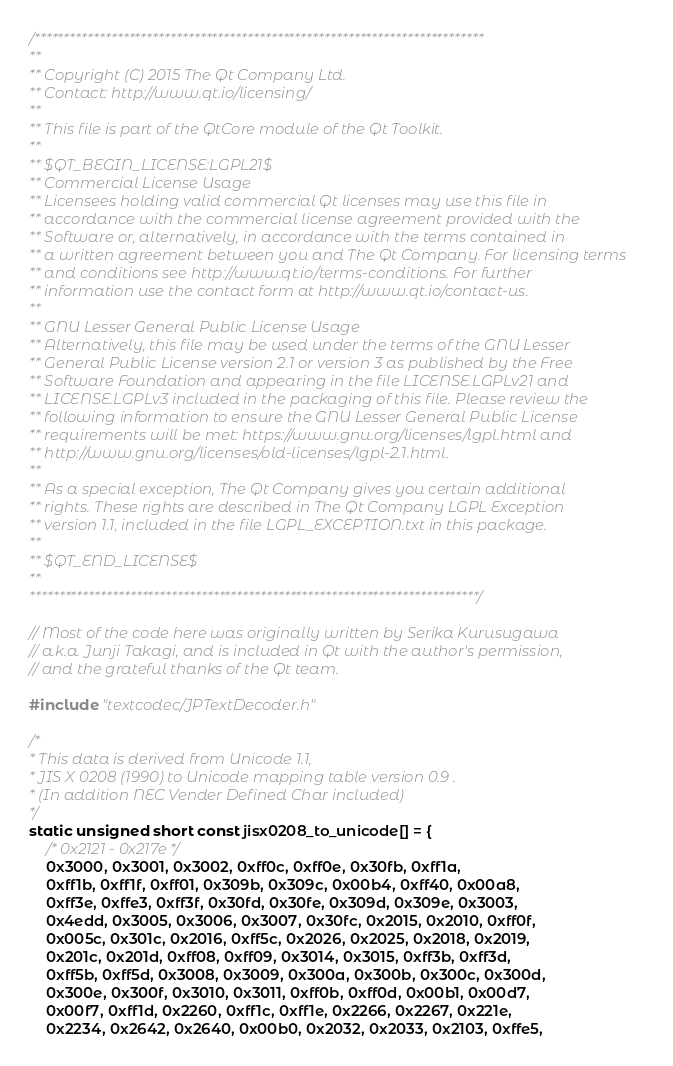<code> <loc_0><loc_0><loc_500><loc_500><_C++_>/****************************************************************************
**
** Copyright (C) 2015 The Qt Company Ltd.
** Contact: http://www.qt.io/licensing/
**
** This file is part of the QtCore module of the Qt Toolkit.
**
** $QT_BEGIN_LICENSE:LGPL21$
** Commercial License Usage
** Licensees holding valid commercial Qt licenses may use this file in
** accordance with the commercial license agreement provided with the
** Software or, alternatively, in accordance with the terms contained in
** a written agreement between you and The Qt Company. For licensing terms
** and conditions see http://www.qt.io/terms-conditions. For further
** information use the contact form at http://www.qt.io/contact-us.
**
** GNU Lesser General Public License Usage
** Alternatively, this file may be used under the terms of the GNU Lesser
** General Public License version 2.1 or version 3 as published by the Free
** Software Foundation and appearing in the file LICENSE.LGPLv21 and
** LICENSE.LGPLv3 included in the packaging of this file. Please review the
** following information to ensure the GNU Lesser General Public License
** requirements will be met: https://www.gnu.org/licenses/lgpl.html and
** http://www.gnu.org/licenses/old-licenses/lgpl-2.1.html.
**
** As a special exception, The Qt Company gives you certain additional
** rights. These rights are described in The Qt Company LGPL Exception
** version 1.1, included in the file LGPL_EXCEPTION.txt in this package.
**
** $QT_END_LICENSE$
**
****************************************************************************/

// Most of the code here was originally written by Serika Kurusugawa
// a.k.a. Junji Takagi, and is included in Qt with the author's permission,
// and the grateful thanks of the Qt team.

#include "textcodec/JPTextDecoder.h"

/*
* This data is derived from Unicode 1.1,
* JIS X 0208 (1990) to Unicode mapping table version 0.9 .
* (In addition NEC Vender Defined Char included)
*/
static unsigned short const jisx0208_to_unicode[] = {
	/* 0x2121 - 0x217e */
	0x3000, 0x3001, 0x3002, 0xff0c, 0xff0e, 0x30fb, 0xff1a,
	0xff1b, 0xff1f, 0xff01, 0x309b, 0x309c, 0x00b4, 0xff40, 0x00a8,
	0xff3e, 0xffe3, 0xff3f, 0x30fd, 0x30fe, 0x309d, 0x309e, 0x3003,
	0x4edd, 0x3005, 0x3006, 0x3007, 0x30fc, 0x2015, 0x2010, 0xff0f,
	0x005c, 0x301c, 0x2016, 0xff5c, 0x2026, 0x2025, 0x2018, 0x2019,
	0x201c, 0x201d, 0xff08, 0xff09, 0x3014, 0x3015, 0xff3b, 0xff3d,
	0xff5b, 0xff5d, 0x3008, 0x3009, 0x300a, 0x300b, 0x300c, 0x300d,
	0x300e, 0x300f, 0x3010, 0x3011, 0xff0b, 0xff0d, 0x00b1, 0x00d7,
	0x00f7, 0xff1d, 0x2260, 0xff1c, 0xff1e, 0x2266, 0x2267, 0x221e,
	0x2234, 0x2642, 0x2640, 0x00b0, 0x2032, 0x2033, 0x2103, 0xffe5,</code> 